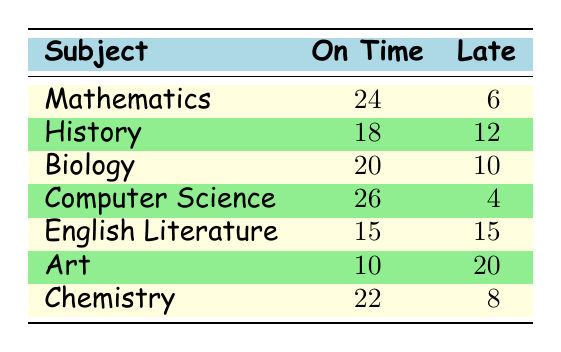What subject had the highest number of assignments completed on time? Looking through the table, Computer Science has the highest count of assignments completed on time with 26 submissions.
Answer: Computer Science How many assignments were completed late in Mathematics? From the table, Mathematics has 6 assignments completed late.
Answer: 6 What is the total number of assignments completed for Biology? For Biology, the total is calculated by adding assignments completed on time (20) and late (10), which gives 20 + 10 = 30.
Answer: 30 Which subject has an equal number of on-time and late assignments? Looking at the table, English Literature has 15 assignments completed on time and 15 assignments completed late, which makes them equal.
Answer: English Literature Is it true that Art has more late assignments than on-time ones? Yes, Art shows 20 late assignments, while only 10 were completed on time, confirming that late assignments are more numerous.
Answer: Yes What is the average number of late assignments across all subjects? To find the average, first sum the late assignments: 6 + 12 + 10 + 4 + 15 + 20 + 8 = 75. Then divide by the total number of subjects (7): 75 / 7 = approximately 10.71.
Answer: 10.71 Which subject has the largest difference between on-time and late assignments? The differences are calculated as follows: Mathematics (24 - 6 = 18), History (18 - 12 = 6), Biology (20 - 10 = 10), Computer Science (26 - 4 = 22), English Literature (15 - 15 = 0), Art (10 - 20 = -10), Chemistry (22 - 8 = 14). The largest difference is in Computer Science with a difference of 22.
Answer: Computer Science How many total assignments were completed on time in Chemistry and Biology combined? The total for Chemistry is 22 and for Biology is 20, so combining them gives 22 + 20 = 42.
Answer: 42 Is the number of assignments completed on time in English Literature higher than in History? Comparing the two, English Literature has 15, while History has 18. Therefore, it is not true that English Literature is higher.
Answer: No 